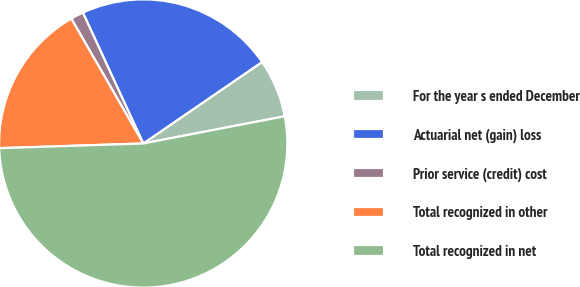Convert chart to OTSL. <chart><loc_0><loc_0><loc_500><loc_500><pie_chart><fcel>For the year s ended December<fcel>Actuarial net (gain) loss<fcel>Prior service (credit) cost<fcel>Total recognized in other<fcel>Total recognized in net<nl><fcel>6.54%<fcel>22.31%<fcel>1.44%<fcel>17.2%<fcel>52.51%<nl></chart> 